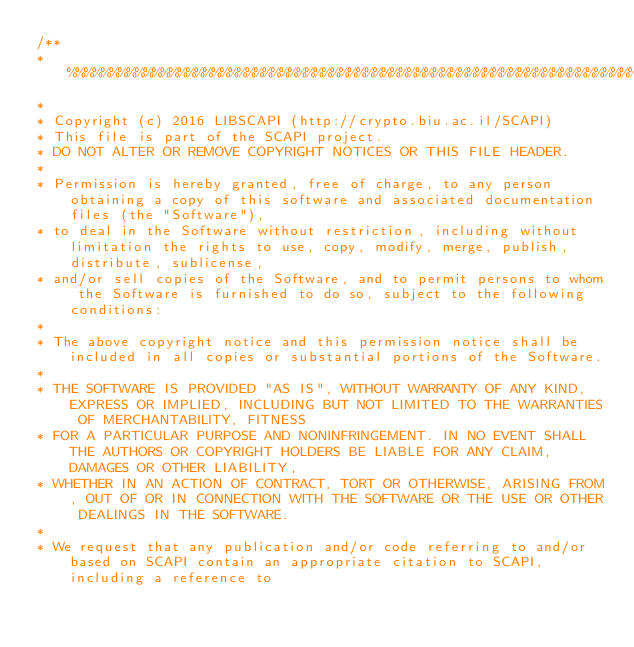Convert code to text. <code><loc_0><loc_0><loc_500><loc_500><_C++_>/**
* %%%%%%%%%%%%%%%%%%%%%%%%%%%%%%%%%%%%%%%%%%%%%%%%%%%%%%%%%%%%%%%%%%%%%%%%%%%%
* 
* Copyright (c) 2016 LIBSCAPI (http://crypto.biu.ac.il/SCAPI)
* This file is part of the SCAPI project.
* DO NOT ALTER OR REMOVE COPYRIGHT NOTICES OR THIS FILE HEADER.
* 
* Permission is hereby granted, free of charge, to any person obtaining a copy of this software and associated documentation files (the "Software"),
* to deal in the Software without restriction, including without limitation the rights to use, copy, modify, merge, publish, distribute, sublicense, 
* and/or sell copies of the Software, and to permit persons to whom the Software is furnished to do so, subject to the following conditions:
* 
* The above copyright notice and this permission notice shall be included in all copies or substantial portions of the Software.
* 
* THE SOFTWARE IS PROVIDED "AS IS", WITHOUT WARRANTY OF ANY KIND, EXPRESS OR IMPLIED, INCLUDING BUT NOT LIMITED TO THE WARRANTIES OF MERCHANTABILITY, FITNESS
* FOR A PARTICULAR PURPOSE AND NONINFRINGEMENT. IN NO EVENT SHALL THE AUTHORS OR COPYRIGHT HOLDERS BE LIABLE FOR ANY CLAIM, DAMAGES OR OTHER LIABILITY,
* WHETHER IN AN ACTION OF CONTRACT, TORT OR OTHERWISE, ARISING FROM, OUT OF OR IN CONNECTION WITH THE SOFTWARE OR THE USE OR OTHER DEALINGS IN THE SOFTWARE.
* 
* We request that any publication and/or code referring to and/or based on SCAPI contain an appropriate citation to SCAPI, including a reference to</code> 